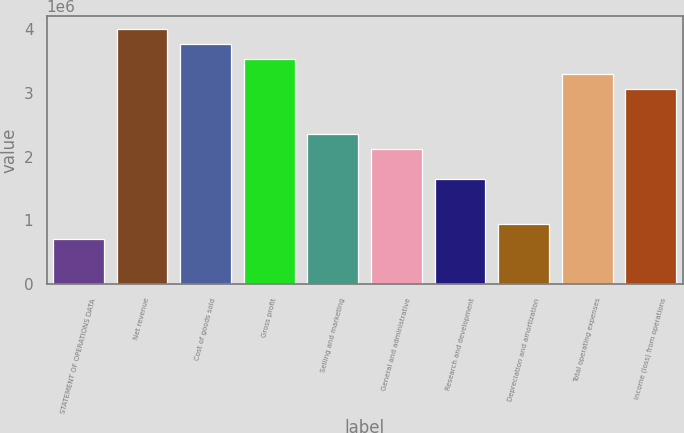Convert chart. <chart><loc_0><loc_0><loc_500><loc_500><bar_chart><fcel>STATEMENT OF OPERATIONS DATA<fcel>Net revenue<fcel>Cost of goods sold<fcel>Gross profit<fcel>Selling and marketing<fcel>General and administrative<fcel>Research and development<fcel>Depreciation and amortization<fcel>Total operating expenses<fcel>Income (loss) from operations<nl><fcel>705173<fcel>3.99596e+06<fcel>3.76091e+06<fcel>3.52585e+06<fcel>2.35057e+06<fcel>2.11551e+06<fcel>1.6454e+06<fcel>940229<fcel>3.29079e+06<fcel>3.05574e+06<nl></chart> 